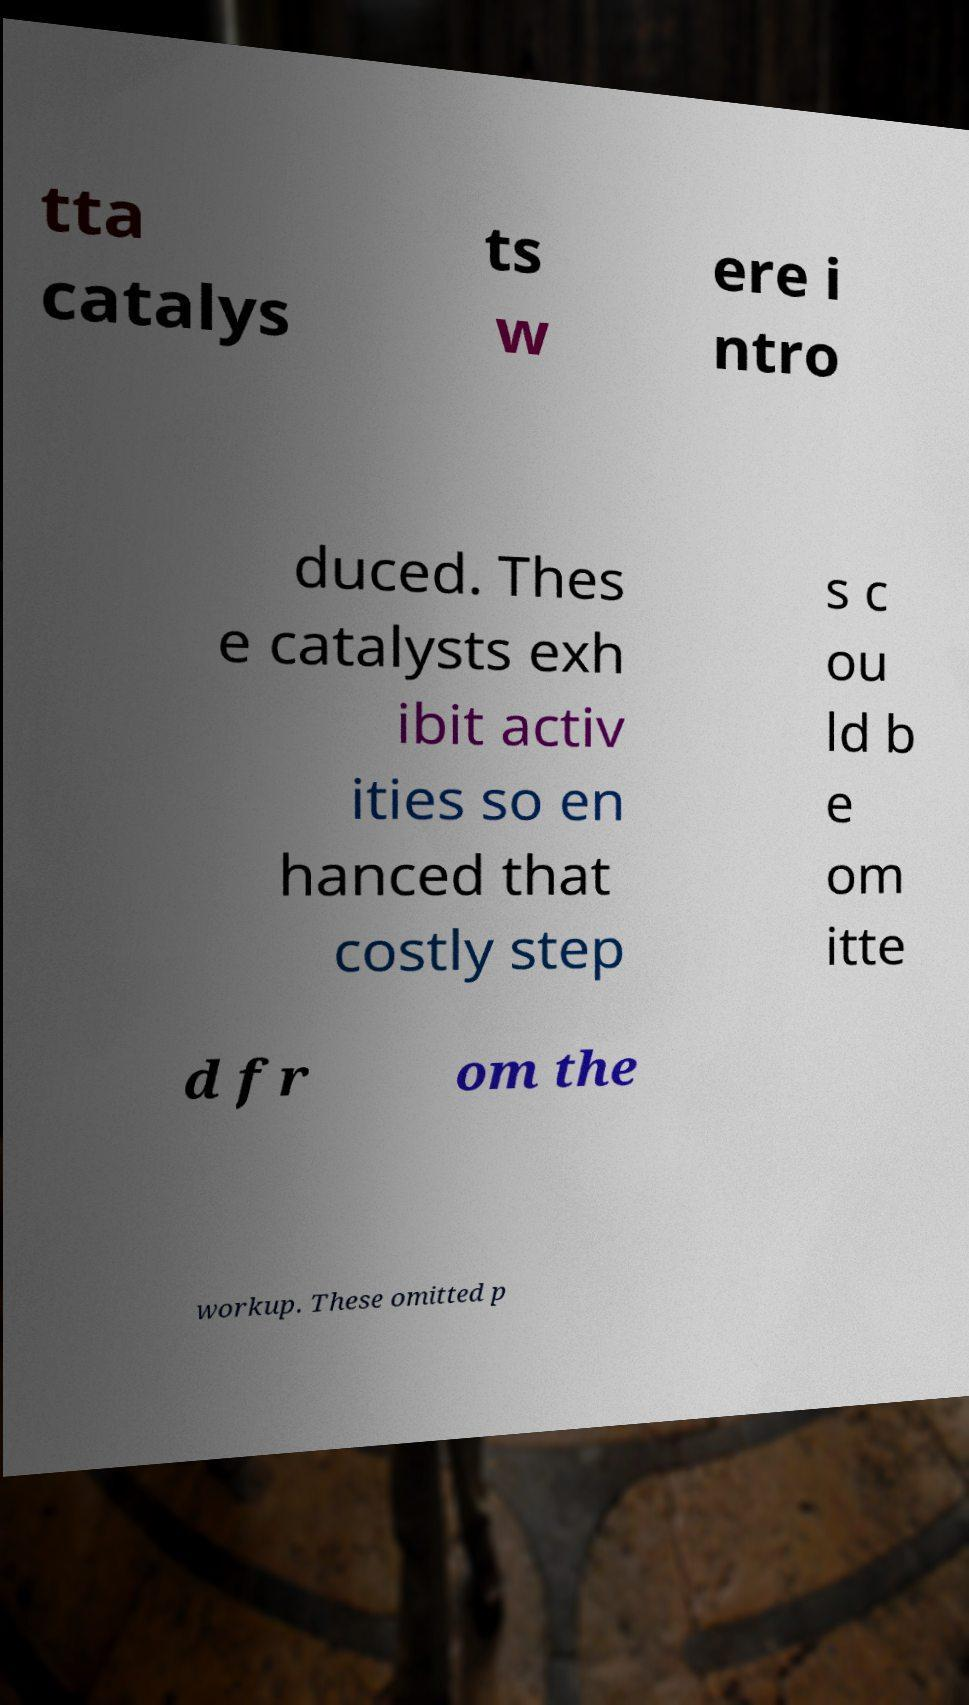Can you read and provide the text displayed in the image?This photo seems to have some interesting text. Can you extract and type it out for me? tta catalys ts w ere i ntro duced. Thes e catalysts exh ibit activ ities so en hanced that costly step s c ou ld b e om itte d fr om the workup. These omitted p 